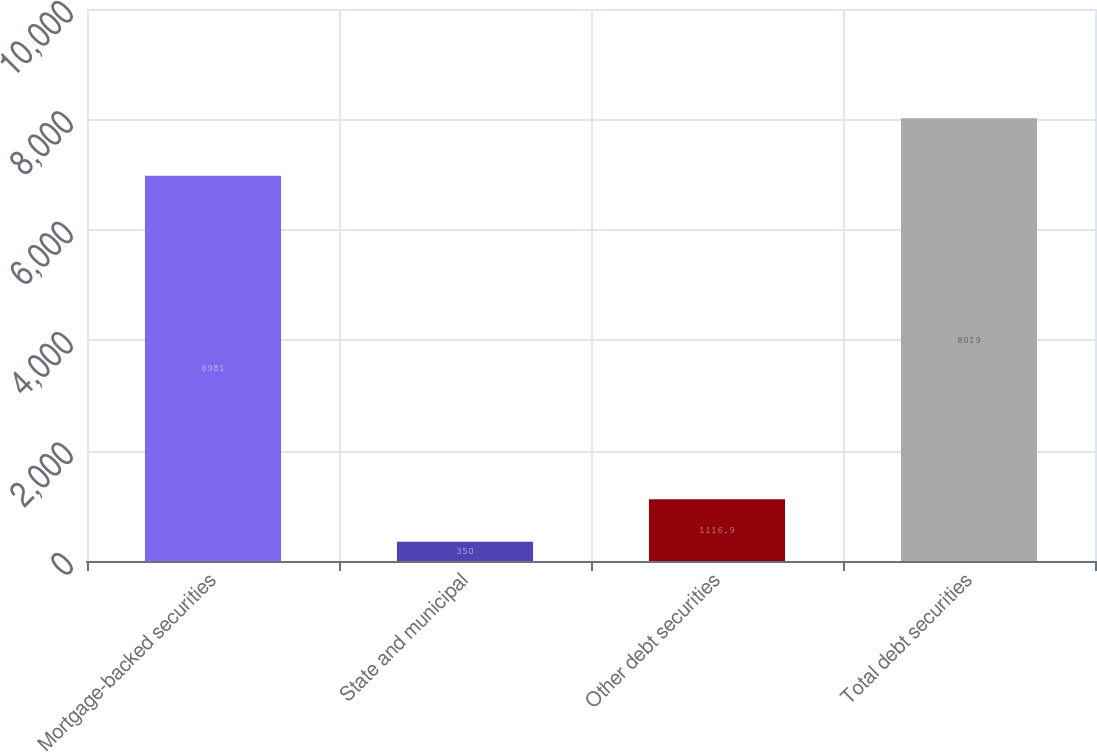Convert chart. <chart><loc_0><loc_0><loc_500><loc_500><bar_chart><fcel>Mortgage-backed securities<fcel>State and municipal<fcel>Other debt securities<fcel>Total debt securities<nl><fcel>6981<fcel>350<fcel>1116.9<fcel>8019<nl></chart> 